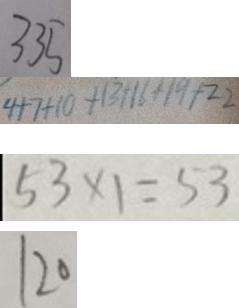Convert formula to latex. <formula><loc_0><loc_0><loc_500><loc_500>3 3 5 
 4 + 7 + 1 0 + 1 3 + 1 6 + 1 9 + 2 2 
 5 3 \times 1 = 5 3 
 1 2 0</formula> 